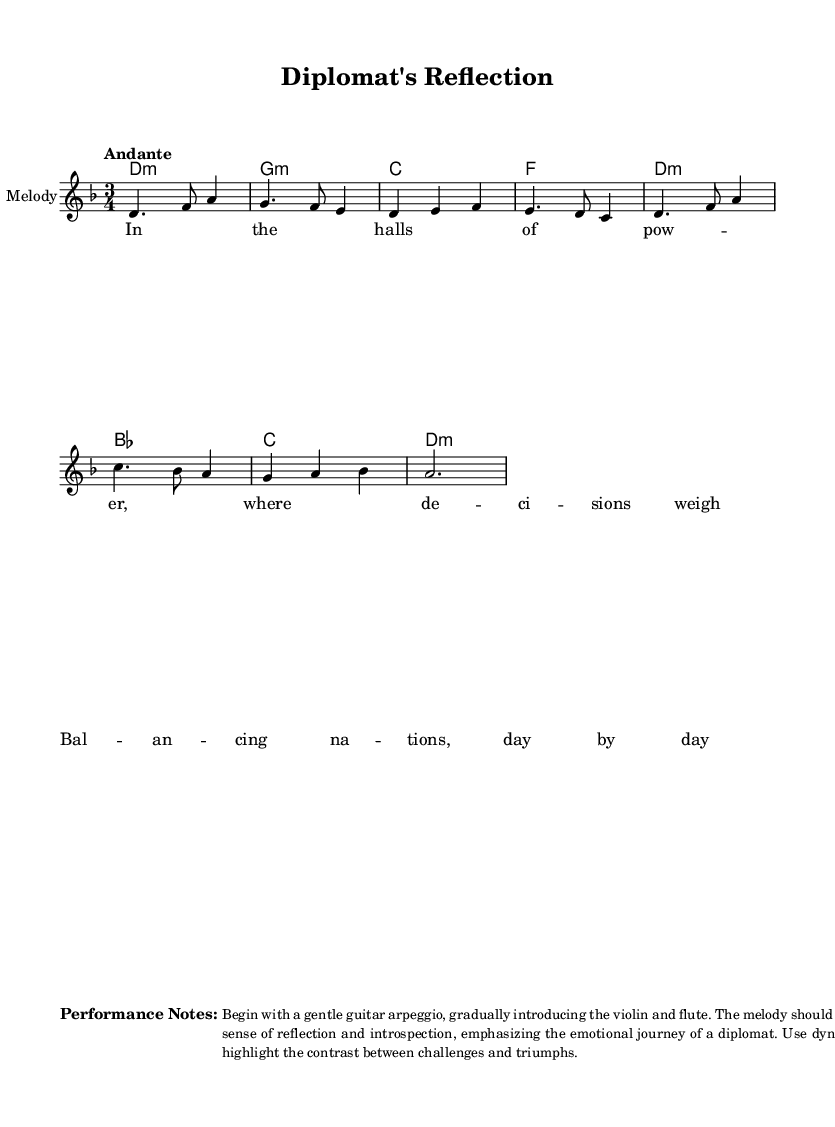What is the key signature of this music? The key signature is indicated at the beginning of the score where the key of D minor is marked, which includes one flat.
Answer: D minor What is the time signature of this piece? The time signature is located at the beginning of the score as well, specified as 3/4, meaning there are three beats per measure.
Answer: 3/4 What is the tempo marking for this piece? The tempo is indicated with the word "Andante" at the beginning of the score, suggesting a moderately slow pace of music.
Answer: Andante How many measures are in the melody? Counting the measures in the melody line, there are a total of eight measures, as each grouping of notes separated by the bar lines constitutes a measure.
Answer: 8 What is the primary emotional theme expressed in the lyrics? The lyrics suggest a theme of struggle and balance in decision-making, specifically highlighting the weight of responsibility in diplomacy, as captured by phrases like "where decisions weigh."
Answer: Responsibility Which instruments are suggested for the performance of this piece? The performance notes indicate beginning with a gentle guitar arpeggio, and gradually introducing the violin and flute, signaling these instruments are essential for the intended sound.
Answer: Guitar, violin, flute What musical form is predominantly featured in the piece? The piece appears to follow a verse structure indicated by the lyrics providing a narrative, which is typical in folk music highlighting storytelling through melody.
Answer: Verse 